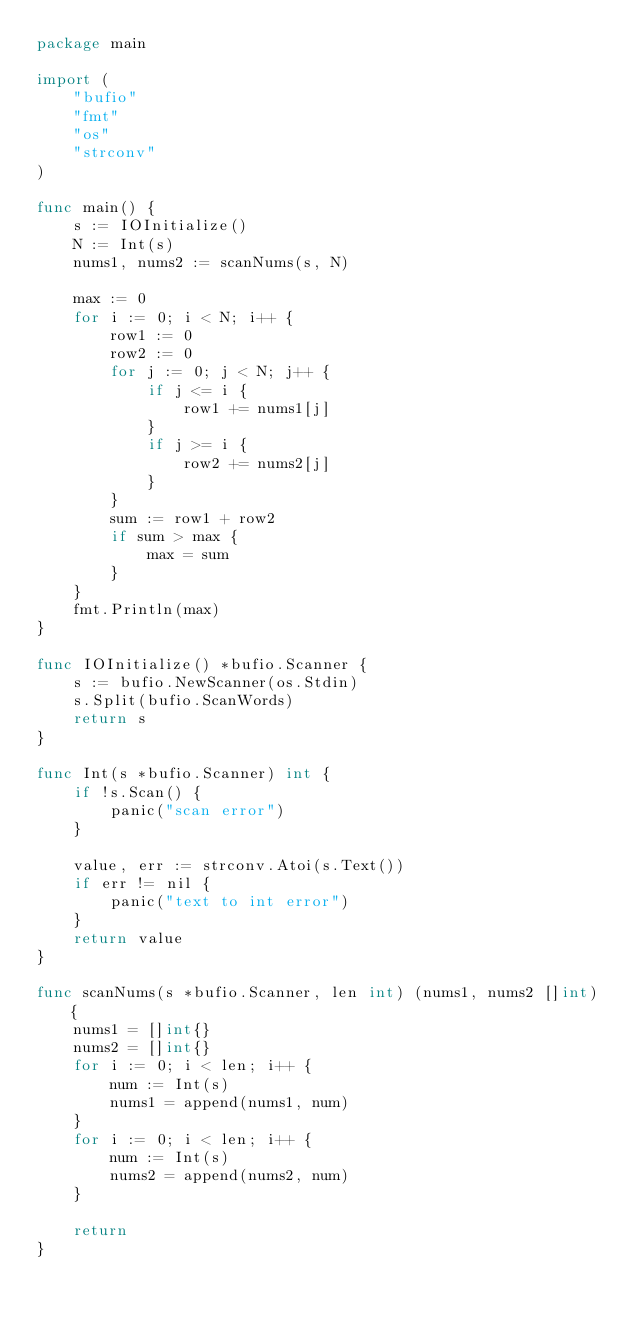Convert code to text. <code><loc_0><loc_0><loc_500><loc_500><_Go_>package main

import (
	"bufio"
	"fmt"
	"os"
	"strconv"
)

func main() {
	s := IOInitialize()
	N := Int(s)
	nums1, nums2 := scanNums(s, N)

	max := 0
	for i := 0; i < N; i++ {
		row1 := 0
		row2 := 0
		for j := 0; j < N; j++ {
			if j <= i {
				row1 += nums1[j]
			}
			if j >= i {
				row2 += nums2[j]
			}
		}
		sum := row1 + row2
		if sum > max {
			max = sum
		}
	}
	fmt.Println(max)
}

func IOInitialize() *bufio.Scanner {
	s := bufio.NewScanner(os.Stdin)
	s.Split(bufio.ScanWords)
	return s
}

func Int(s *bufio.Scanner) int {
	if !s.Scan() {
		panic("scan error")
	}

	value, err := strconv.Atoi(s.Text())
	if err != nil {
		panic("text to int error")
	}
	return value
}

func scanNums(s *bufio.Scanner, len int) (nums1, nums2 []int) {
	nums1 = []int{}
	nums2 = []int{}
	for i := 0; i < len; i++ {
		num := Int(s)
		nums1 = append(nums1, num)
	}
	for i := 0; i < len; i++ {
		num := Int(s)
		nums2 = append(nums2, num)
	}

	return
}
</code> 